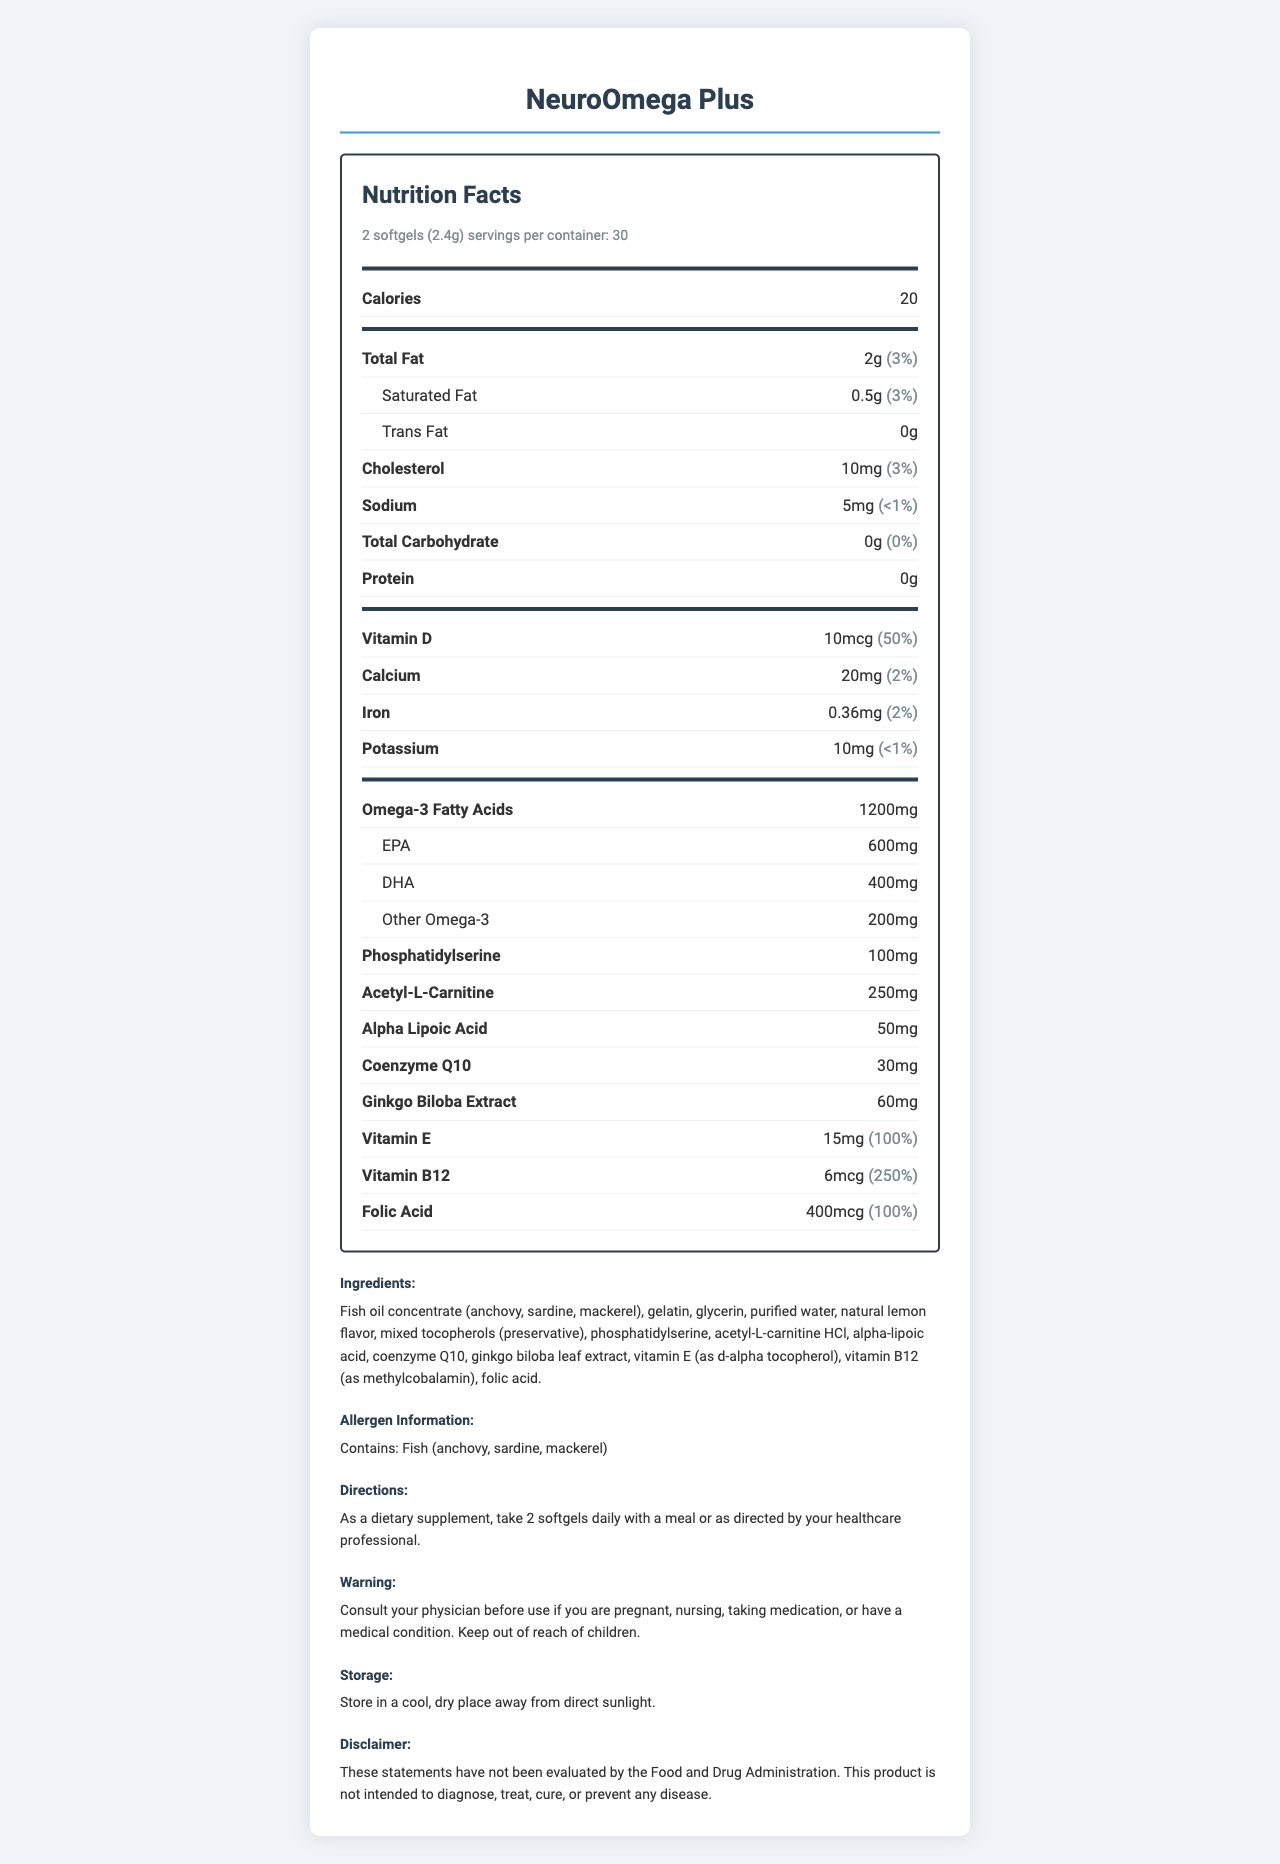what is the serving size of NeuroOmega Plus? The serving size is indicated at the top portion of the nutrition facts under “serving size.”
Answer: 2 softgels (2.4g) how many calories are in a serving of NeuroOmega Plus? The calories per serving are listed immediately under the serving size and the number of servings per container.
Answer: 20 calories how much EPA is included in the Omega-3 Fatty Acids of NeuroOmega Plus? The breakdown of the Omega-3 Fatty Acids content specifies that there are 600mg of EPA.
Answer: 600mg what is the daily value percentage of Vitamin D per serving? The daily value percentage for Vitamin D is listed as 50% alongside its amount.
Answer: 50% how much Acetyl-L-Carnitine is in the supplement per serving? Acetyl-L-Carnitine content is provided in the nutrient section as 250mg per serving.
Answer: 250mg how many servings are there per container? The number of servings per container is listed near the top of the document.
Answer: 30 does the product contain any trans fat? The document specifies "0g" for Trans Fat.
Answer: No how much cholesterol is in each serving? The cholesterol amount per serving is listed as 10mg.
Answer: 10mg what flavoring is used in the product? The ingredients list mentions "natural lemon flavor."
Answer: Natural lemon flavor what percentage of the daily value for Vitamin E is provided by each serving? The daily value percentage for Vitamin E is provided as 100% in the nutrient breakdown.
Answer: 100% which of the following is a part of the NeuroOmega Plus supplement? A. Aspirin B. Phosphatidylserine C. Glucosamine The ingredients section lists Phosphatidylserine as part of the supplement.
Answer: B. Phosphatidylserine what is the total amount of omega-3 fatty acids in a serving of NeuroOmega Plus? A. 800mg B. 1000mg C. 1200mg D. 1500mg The total Omega-3 Fatty Acids content is explicitly listed as 1200mg.
Answer: C. 1200mg is there any sodium content in the supplement? The document specifies that there is 5mg of sodium per serving.
Answer: Yes summarize the main components of this document The main idea of the document is to present the nutritional information, ingredients, and additional usage instructions for the NeuroOmega Plus supplement.
Answer: NeuroOmega Plus is a brain health supplement with 30 servings per container. Each serving contains 20 calories and a variety of nutrients including Omega-3 Fatty Acids (1200mg), phosphatidylserine (100mg), and vitamins like D, E, and B12. The supplement also includes ingredients such as fish oil concentrate, gelatin, and natural lemon flavor. It contains fish allergens and comes with specific directions and warnings. what is the primary source of Omega-3 in NeuroOmega Plus? The document mentions "fish oil concentrate" but does not specify which type of fish primarily contributes to the Omega-3 content.
Answer: Cannot be determined 